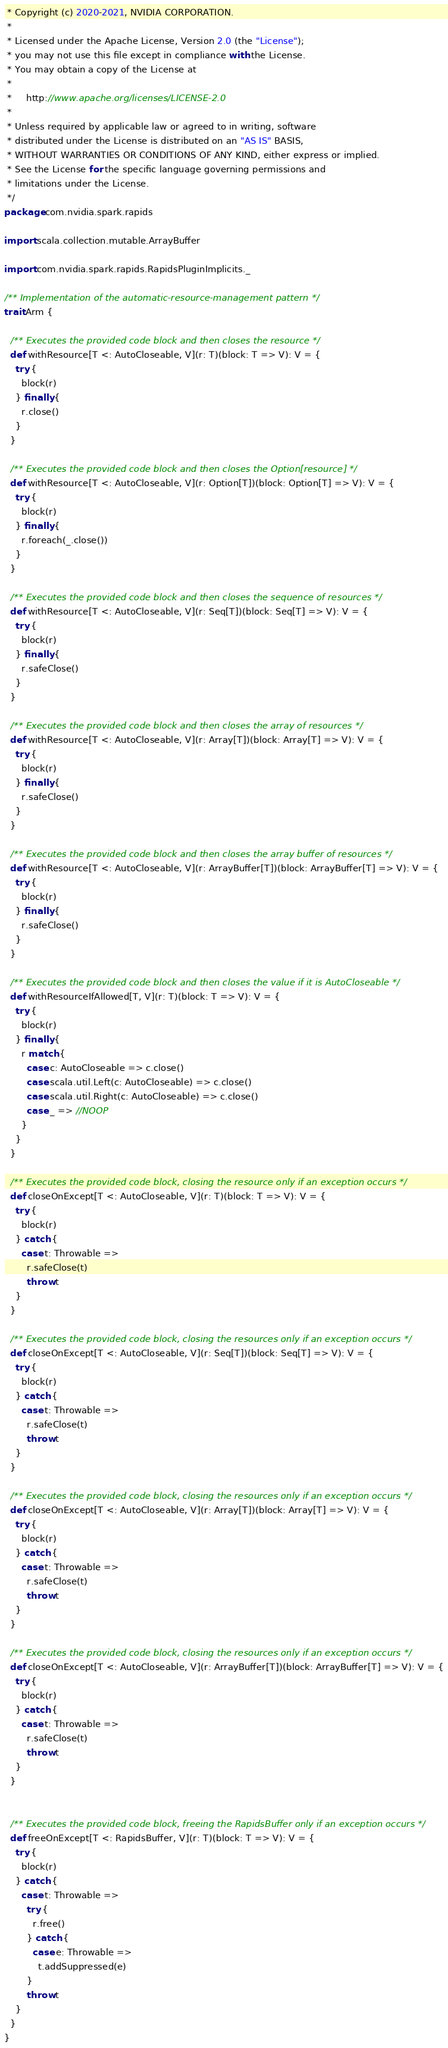<code> <loc_0><loc_0><loc_500><loc_500><_Scala_> * Copyright (c) 2020-2021, NVIDIA CORPORATION.
 *
 * Licensed under the Apache License, Version 2.0 (the "License");
 * you may not use this file except in compliance with the License.
 * You may obtain a copy of the License at
 *
 *     http://www.apache.org/licenses/LICENSE-2.0
 *
 * Unless required by applicable law or agreed to in writing, software
 * distributed under the License is distributed on an "AS IS" BASIS,
 * WITHOUT WARRANTIES OR CONDITIONS OF ANY KIND, either express or implied.
 * See the License for the specific language governing permissions and
 * limitations under the License.
 */
package com.nvidia.spark.rapids

import scala.collection.mutable.ArrayBuffer

import com.nvidia.spark.rapids.RapidsPluginImplicits._

/** Implementation of the automatic-resource-management pattern */
trait Arm {

  /** Executes the provided code block and then closes the resource */
  def withResource[T <: AutoCloseable, V](r: T)(block: T => V): V = {
    try {
      block(r)
    } finally {
      r.close()
    }
  }

  /** Executes the provided code block and then closes the Option[resource] */
  def withResource[T <: AutoCloseable, V](r: Option[T])(block: Option[T] => V): V = {
    try {
      block(r)
    } finally {
      r.foreach(_.close())
    }
  }

  /** Executes the provided code block and then closes the sequence of resources */
  def withResource[T <: AutoCloseable, V](r: Seq[T])(block: Seq[T] => V): V = {
    try {
      block(r)
    } finally {
      r.safeClose()
    }
  }

  /** Executes the provided code block and then closes the array of resources */
  def withResource[T <: AutoCloseable, V](r: Array[T])(block: Array[T] => V): V = {
    try {
      block(r)
    } finally {
      r.safeClose()
    }
  }

  /** Executes the provided code block and then closes the array buffer of resources */
  def withResource[T <: AutoCloseable, V](r: ArrayBuffer[T])(block: ArrayBuffer[T] => V): V = {
    try {
      block(r)
    } finally {
      r.safeClose()
    }
  }

  /** Executes the provided code block and then closes the value if it is AutoCloseable */
  def withResourceIfAllowed[T, V](r: T)(block: T => V): V = {
    try {
      block(r)
    } finally {
      r match {
        case c: AutoCloseable => c.close()
        case scala.util.Left(c: AutoCloseable) => c.close()
        case scala.util.Right(c: AutoCloseable) => c.close()
        case _ => //NOOP
      }
    }
  }

  /** Executes the provided code block, closing the resource only if an exception occurs */
  def closeOnExcept[T <: AutoCloseable, V](r: T)(block: T => V): V = {
    try {
      block(r)
    } catch {
      case t: Throwable =>
        r.safeClose(t)
        throw t
    }
  }

  /** Executes the provided code block, closing the resources only if an exception occurs */
  def closeOnExcept[T <: AutoCloseable, V](r: Seq[T])(block: Seq[T] => V): V = {
    try {
      block(r)
    } catch {
      case t: Throwable =>
        r.safeClose(t)
        throw t
    }
  }

  /** Executes the provided code block, closing the resources only if an exception occurs */
  def closeOnExcept[T <: AutoCloseable, V](r: Array[T])(block: Array[T] => V): V = {
    try {
      block(r)
    } catch {
      case t: Throwable =>
        r.safeClose(t)
        throw t
    }
  }

  /** Executes the provided code block, closing the resources only if an exception occurs */
  def closeOnExcept[T <: AutoCloseable, V](r: ArrayBuffer[T])(block: ArrayBuffer[T] => V): V = {
    try {
      block(r)
    } catch {
      case t: Throwable =>
        r.safeClose(t)
        throw t
    }
  }


  /** Executes the provided code block, freeing the RapidsBuffer only if an exception occurs */
  def freeOnExcept[T <: RapidsBuffer, V](r: T)(block: T => V): V = {
    try {
      block(r)
    } catch {
      case t: Throwable =>
        try {
          r.free()
        } catch {
          case e: Throwable =>
            t.addSuppressed(e)
        }
        throw t
    }
  }
}
</code> 